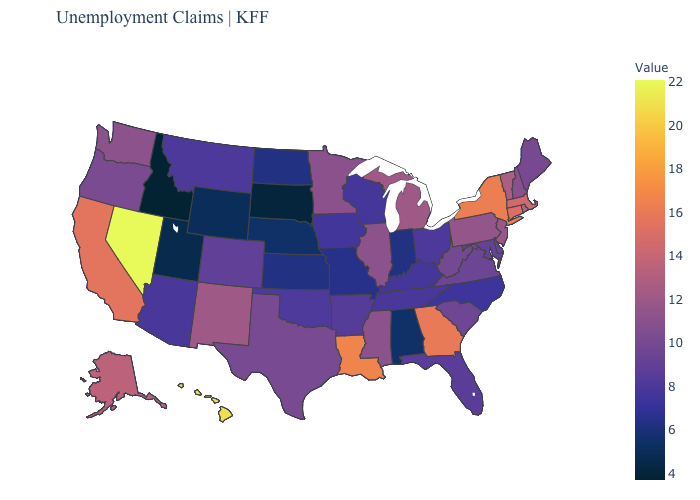Which states have the lowest value in the Northeast?
Be succinct. Maine. Among the states that border New York , does Connecticut have the highest value?
Concise answer only. Yes. Does the map have missing data?
Be succinct. No. Does the map have missing data?
Short answer required. No. Which states hav the highest value in the MidWest?
Give a very brief answer. Michigan. Does Mississippi have the highest value in the USA?
Give a very brief answer. No. 